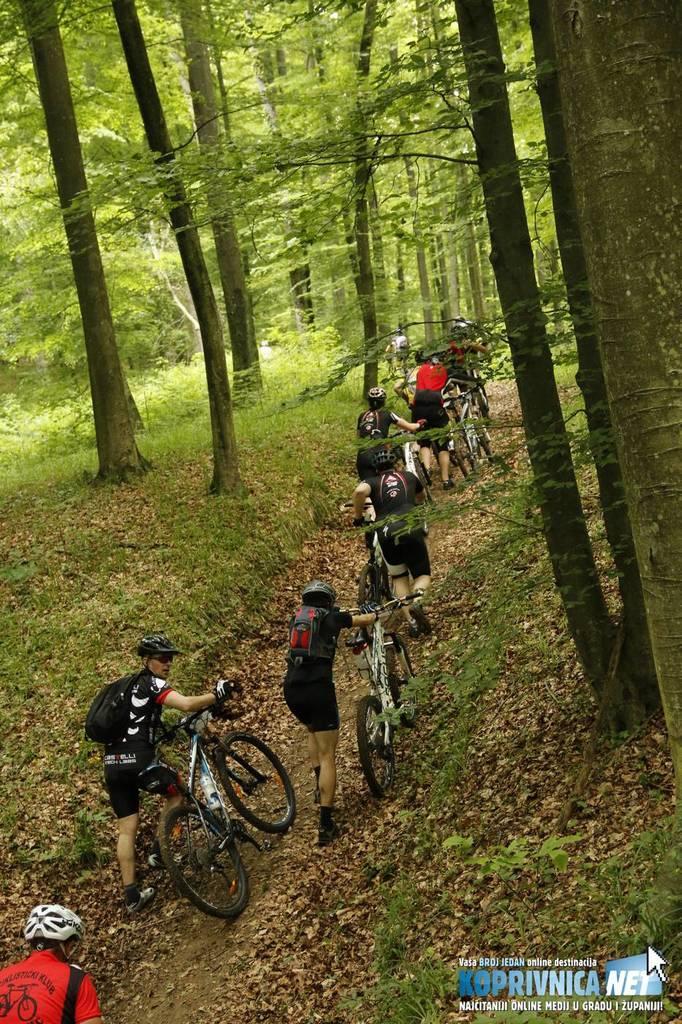Describe this image in one or two sentences. In this image there are bicycles and the people are holding those bicycles. People are wearing bags, helmet. There are trees on the top. 